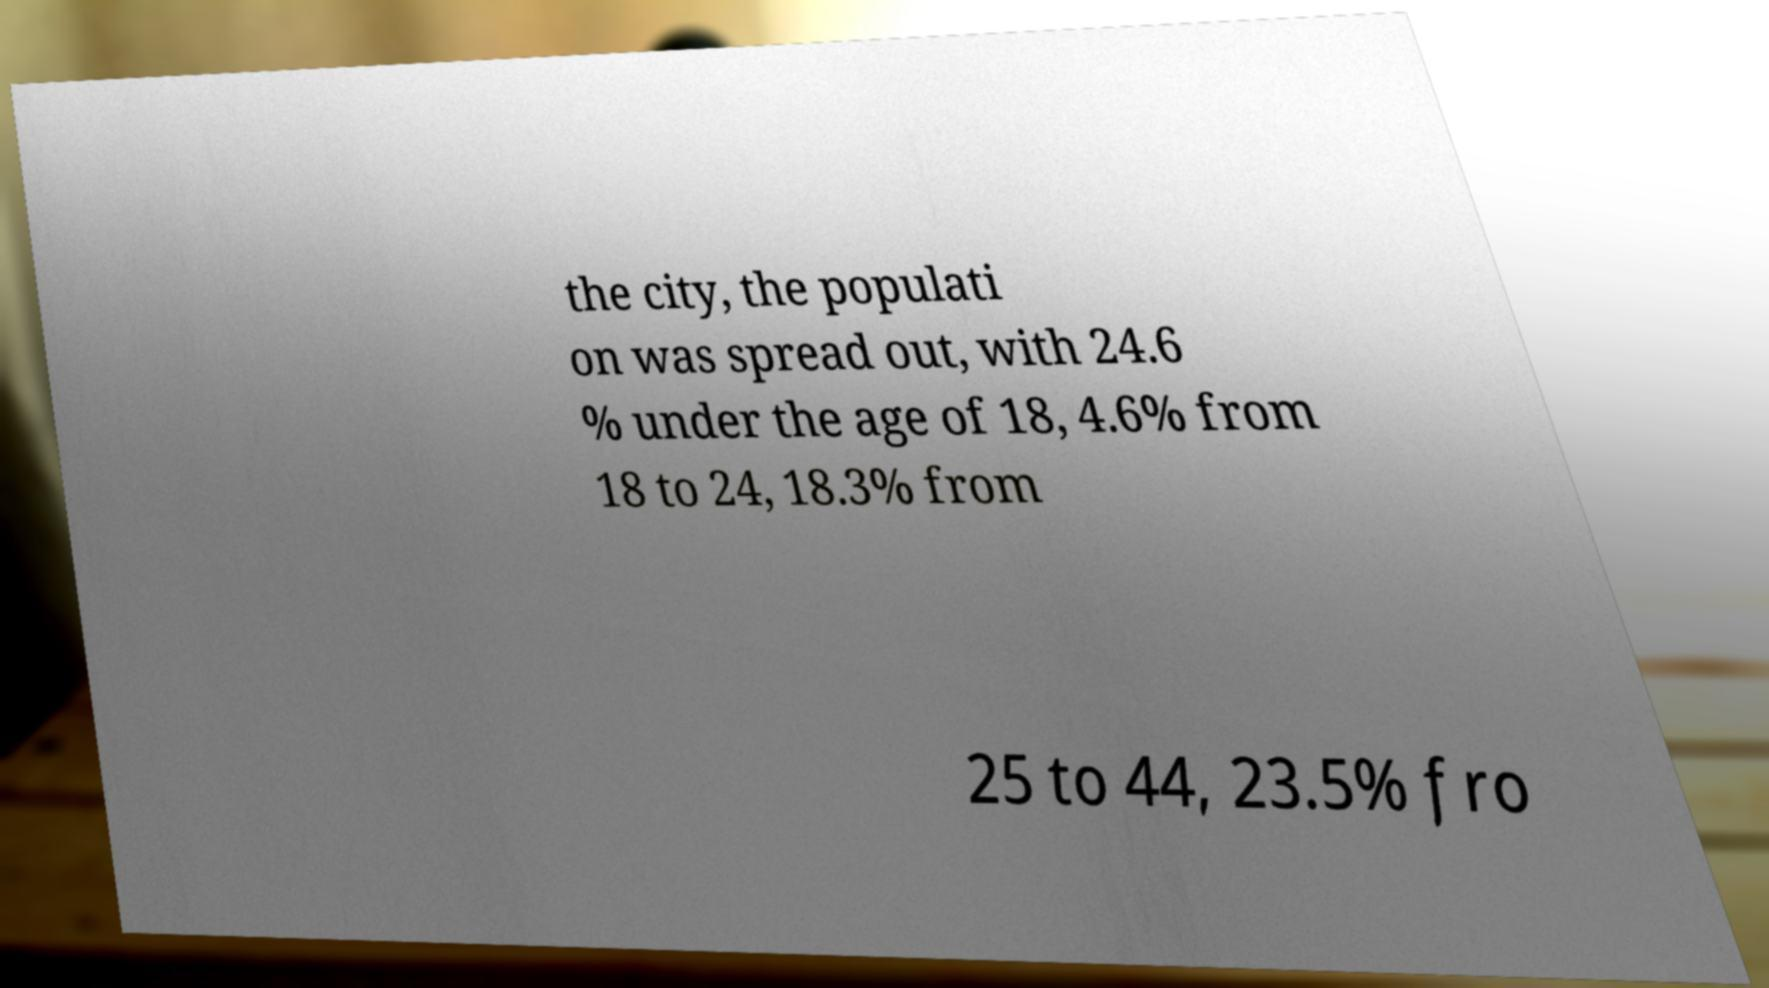Can you read and provide the text displayed in the image?This photo seems to have some interesting text. Can you extract and type it out for me? the city, the populati on was spread out, with 24.6 % under the age of 18, 4.6% from 18 to 24, 18.3% from 25 to 44, 23.5% fro 